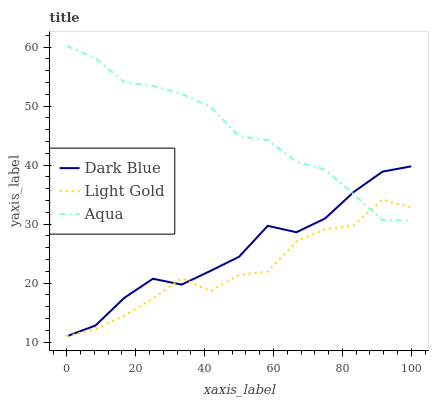Does Light Gold have the minimum area under the curve?
Answer yes or no. Yes. Does Aqua have the maximum area under the curve?
Answer yes or no. Yes. Does Dark Blue have the minimum area under the curve?
Answer yes or no. No. Does Dark Blue have the maximum area under the curve?
Answer yes or no. No. Is Aqua the smoothest?
Answer yes or no. Yes. Is Light Gold the roughest?
Answer yes or no. Yes. Is Dark Blue the smoothest?
Answer yes or no. No. Is Dark Blue the roughest?
Answer yes or no. No. Does Dark Blue have the lowest value?
Answer yes or no. Yes. Does Aqua have the highest value?
Answer yes or no. Yes. Does Dark Blue have the highest value?
Answer yes or no. No. Does Dark Blue intersect Light Gold?
Answer yes or no. Yes. Is Dark Blue less than Light Gold?
Answer yes or no. No. Is Dark Blue greater than Light Gold?
Answer yes or no. No. 